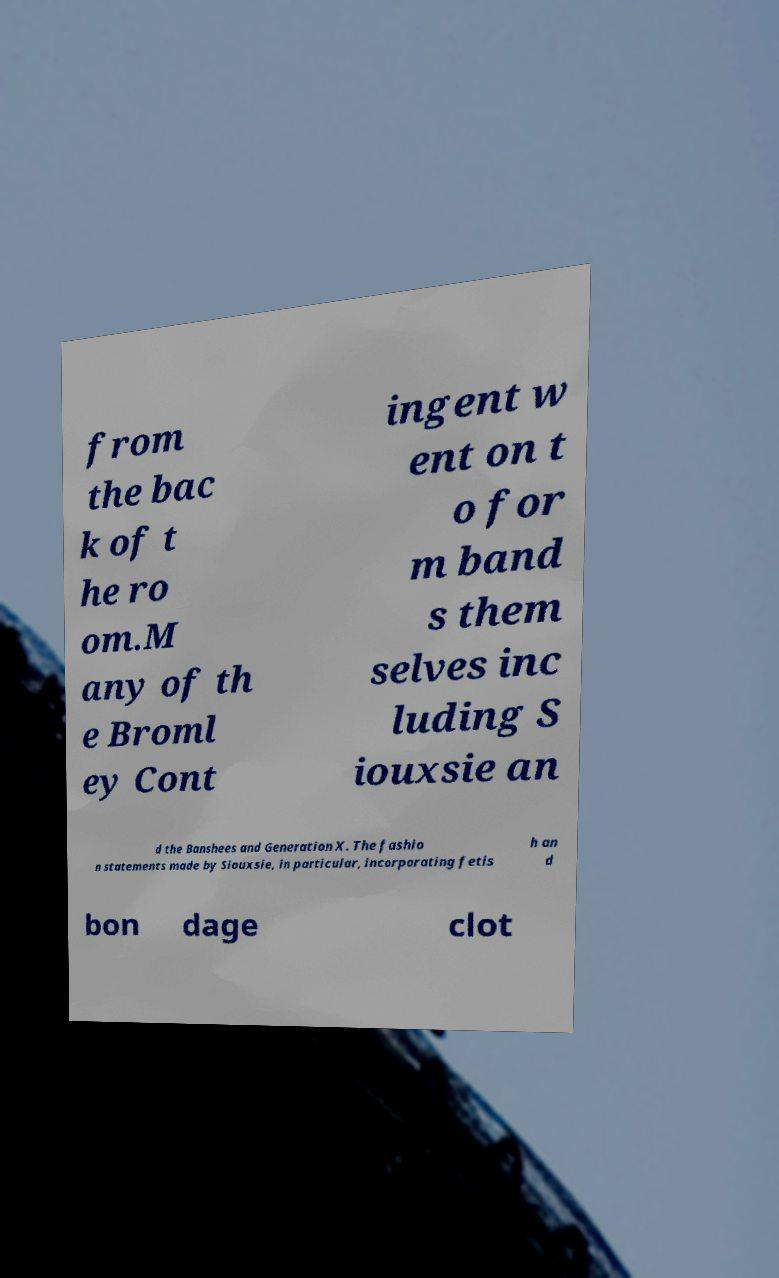I need the written content from this picture converted into text. Can you do that? from the bac k of t he ro om.M any of th e Broml ey Cont ingent w ent on t o for m band s them selves inc luding S iouxsie an d the Banshees and Generation X. The fashio n statements made by Siouxsie, in particular, incorporating fetis h an d bon dage clot 